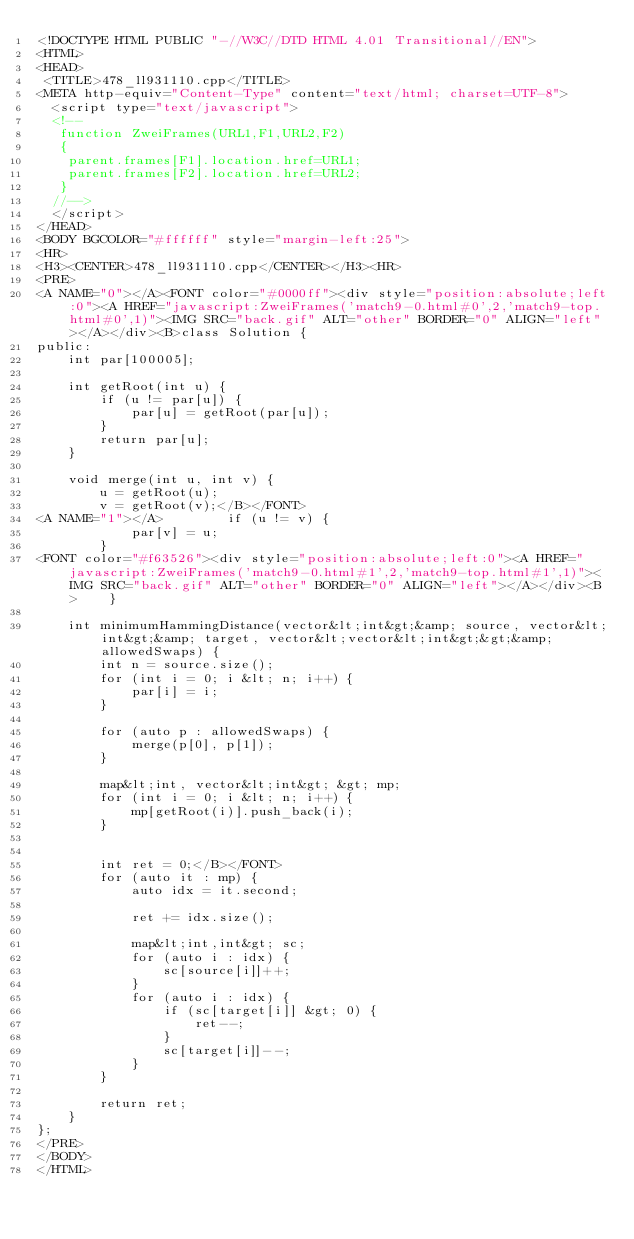Convert code to text. <code><loc_0><loc_0><loc_500><loc_500><_HTML_><!DOCTYPE HTML PUBLIC "-//W3C//DTD HTML 4.01 Transitional//EN">
<HTML>
<HEAD>
 <TITLE>478_ll931110.cpp</TITLE>
<META http-equiv="Content-Type" content="text/html; charset=UTF-8">
  <script type="text/javascript">
  <!--
   function ZweiFrames(URL1,F1,URL2,F2)
   {
    parent.frames[F1].location.href=URL1;
    parent.frames[F2].location.href=URL2;
   }
  //-->
  </script>
</HEAD>
<BODY BGCOLOR="#ffffff" style="margin-left:25">
<HR>
<H3><CENTER>478_ll931110.cpp</CENTER></H3><HR>
<PRE>
<A NAME="0"></A><FONT color="#0000ff"><div style="position:absolute;left:0"><A HREF="javascript:ZweiFrames('match9-0.html#0',2,'match9-top.html#0',1)"><IMG SRC="back.gif" ALT="other" BORDER="0" ALIGN="left"></A></div><B>class Solution {
public:
    int par[100005];
    
    int getRoot(int u) {
        if (u != par[u]) {
            par[u] = getRoot(par[u]);
        }
        return par[u];
    }
   
    void merge(int u, int v) {
        u = getRoot(u);
        v = getRoot(v);</B></FONT>
<A NAME="1"></A>        if (u != v) {
            par[v] = u;
        }
<FONT color="#f63526"><div style="position:absolute;left:0"><A HREF="javascript:ZweiFrames('match9-0.html#1',2,'match9-top.html#1',1)"><IMG SRC="back.gif" ALT="other" BORDER="0" ALIGN="left"></A></div><B>    }
    
    int minimumHammingDistance(vector&lt;int&gt;&amp; source, vector&lt;int&gt;&amp; target, vector&lt;vector&lt;int&gt;&gt;&amp; allowedSwaps) {
        int n = source.size();
        for (int i = 0; i &lt; n; i++) {
            par[i] = i;
        }
        
        for (auto p : allowedSwaps) {
            merge(p[0], p[1]);
        }
        
        map&lt;int, vector&lt;int&gt; &gt; mp;
        for (int i = 0; i &lt; n; i++) {
            mp[getRoot(i)].push_back(i);
        }
        
        
        int ret = 0;</B></FONT>
        for (auto it : mp) {
            auto idx = it.second;
            
            ret += idx.size();
            
            map&lt;int,int&gt; sc;
            for (auto i : idx) {
                sc[source[i]]++;
            }
            for (auto i : idx) {
                if (sc[target[i]] &gt; 0) {
                    ret--;
                }
                sc[target[i]]--;
            }
        }
        
        return ret;
    }
};
</PRE>
</BODY>
</HTML>
</code> 